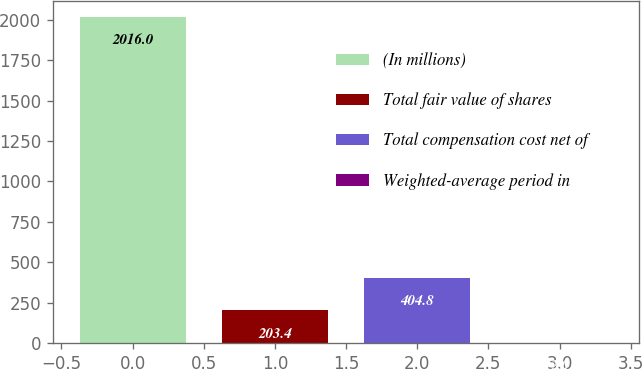<chart> <loc_0><loc_0><loc_500><loc_500><bar_chart><fcel>(In millions)<fcel>Total fair value of shares<fcel>Total compensation cost net of<fcel>Weighted-average period in<nl><fcel>2016<fcel>203.4<fcel>404.8<fcel>2<nl></chart> 